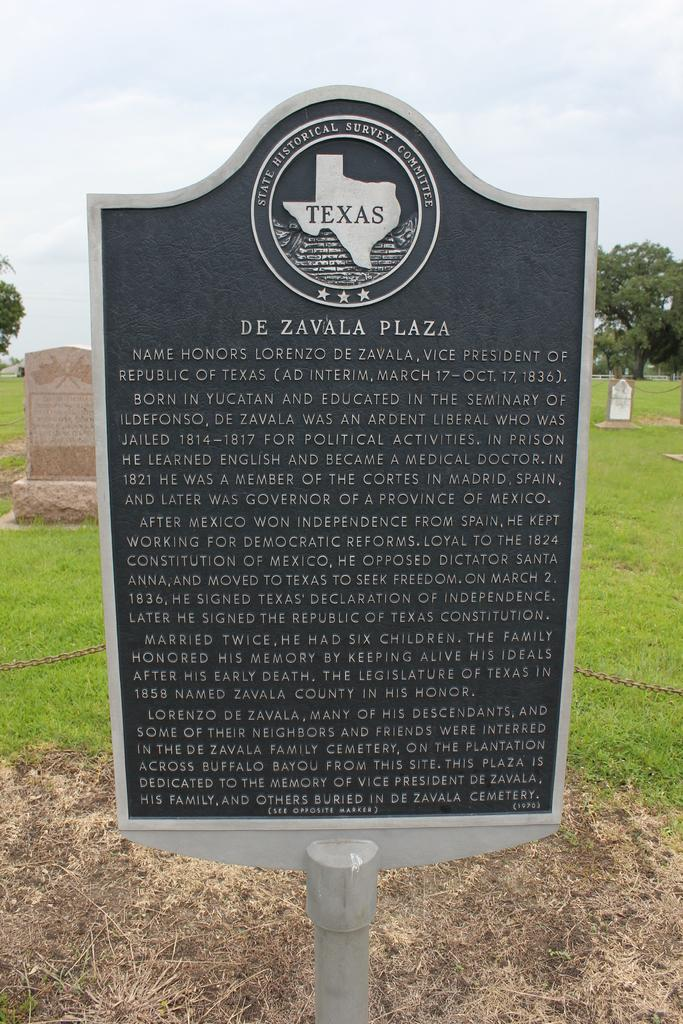What is on the board that is visible in the image? There is text on the board in the image. What type of location is depicted in the image? There is a graveyard on the grass in the image. What can be seen in the background of the image? Trees and the sky are visible in the background of the image. What type of leg can be seen in the image? There is no leg present in the image. What type of drink is being offered in the image? There is no drink present in the image. 